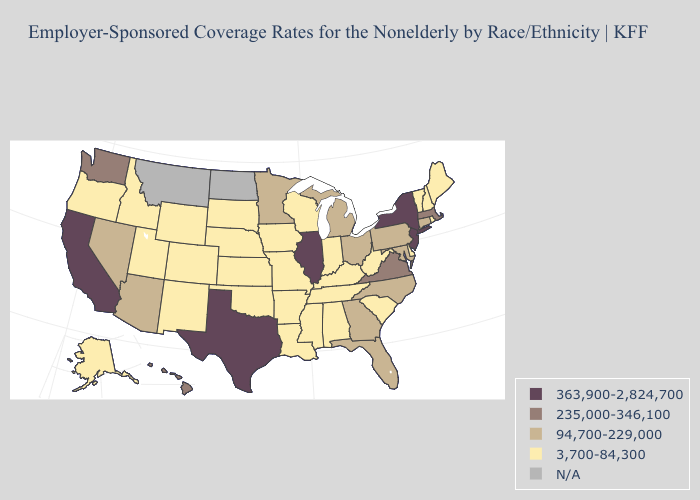Name the states that have a value in the range N/A?
Keep it brief. Montana, North Dakota. Which states have the lowest value in the Northeast?
Give a very brief answer. Maine, New Hampshire, Rhode Island, Vermont. Name the states that have a value in the range N/A?
Be succinct. Montana, North Dakota. Name the states that have a value in the range 235,000-346,100?
Be succinct. Hawaii, Massachusetts, Virginia, Washington. Does the map have missing data?
Quick response, please. Yes. Which states hav the highest value in the MidWest?
Quick response, please. Illinois. Does Michigan have the lowest value in the MidWest?
Give a very brief answer. No. What is the value of Louisiana?
Give a very brief answer. 3,700-84,300. Which states have the lowest value in the USA?
Be succinct. Alabama, Alaska, Arkansas, Colorado, Delaware, Idaho, Indiana, Iowa, Kansas, Kentucky, Louisiana, Maine, Mississippi, Missouri, Nebraska, New Hampshire, New Mexico, Oklahoma, Oregon, Rhode Island, South Carolina, South Dakota, Tennessee, Utah, Vermont, West Virginia, Wisconsin, Wyoming. Name the states that have a value in the range 363,900-2,824,700?
Quick response, please. California, Illinois, New Jersey, New York, Texas. Name the states that have a value in the range N/A?
Concise answer only. Montana, North Dakota. Among the states that border New York , does Vermont have the lowest value?
Write a very short answer. Yes. 